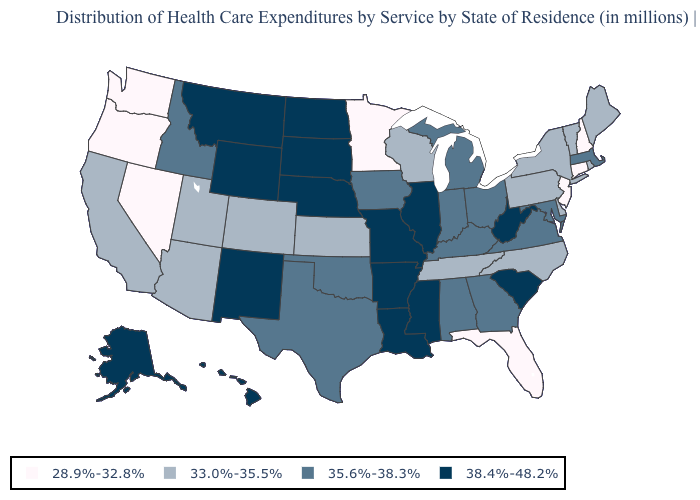What is the value of Alabama?
Quick response, please. 35.6%-38.3%. Name the states that have a value in the range 33.0%-35.5%?
Write a very short answer. Arizona, California, Colorado, Delaware, Kansas, Maine, New York, North Carolina, Pennsylvania, Rhode Island, Tennessee, Utah, Vermont, Wisconsin. What is the value of Vermont?
Answer briefly. 33.0%-35.5%. Name the states that have a value in the range 35.6%-38.3%?
Keep it brief. Alabama, Georgia, Idaho, Indiana, Iowa, Kentucky, Maryland, Massachusetts, Michigan, Ohio, Oklahoma, Texas, Virginia. Name the states that have a value in the range 35.6%-38.3%?
Write a very short answer. Alabama, Georgia, Idaho, Indiana, Iowa, Kentucky, Maryland, Massachusetts, Michigan, Ohio, Oklahoma, Texas, Virginia. Is the legend a continuous bar?
Give a very brief answer. No. What is the value of Maryland?
Write a very short answer. 35.6%-38.3%. Among the states that border Oklahoma , which have the highest value?
Answer briefly. Arkansas, Missouri, New Mexico. What is the highest value in the USA?
Concise answer only. 38.4%-48.2%. Does Florida have a lower value than Alaska?
Keep it brief. Yes. Name the states that have a value in the range 28.9%-32.8%?
Quick response, please. Connecticut, Florida, Minnesota, Nevada, New Hampshire, New Jersey, Oregon, Washington. How many symbols are there in the legend?
Be succinct. 4. Name the states that have a value in the range 33.0%-35.5%?
Short answer required. Arizona, California, Colorado, Delaware, Kansas, Maine, New York, North Carolina, Pennsylvania, Rhode Island, Tennessee, Utah, Vermont, Wisconsin. Does the first symbol in the legend represent the smallest category?
Be succinct. Yes. 